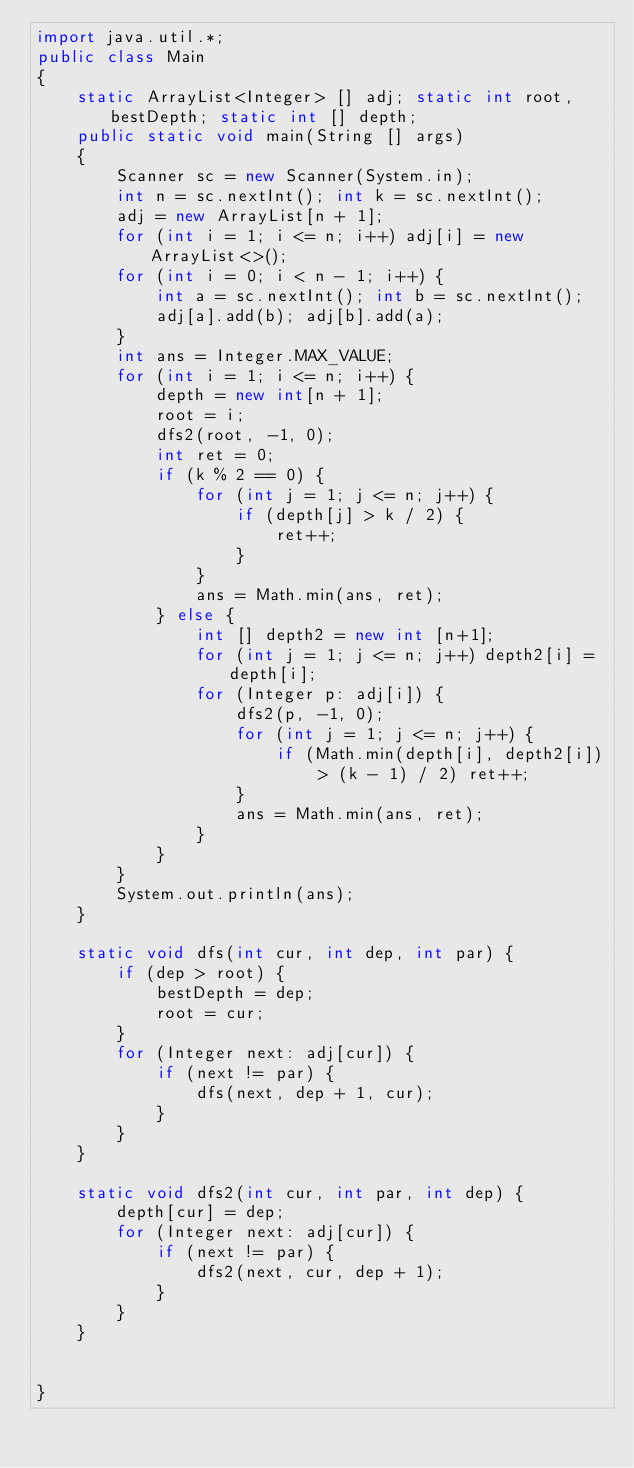Convert code to text. <code><loc_0><loc_0><loc_500><loc_500><_Java_>import java.util.*;
public class Main
{
    static ArrayList<Integer> [] adj; static int root, bestDepth; static int [] depth;
    public static void main(String [] args)
    {
        Scanner sc = new Scanner(System.in);
        int n = sc.nextInt(); int k = sc.nextInt();
        adj = new ArrayList[n + 1];
        for (int i = 1; i <= n; i++) adj[i] = new ArrayList<>();
        for (int i = 0; i < n - 1; i++) {
            int a = sc.nextInt(); int b = sc.nextInt();
            adj[a].add(b); adj[b].add(a);
        }
        int ans = Integer.MAX_VALUE;
        for (int i = 1; i <= n; i++) {
            depth = new int[n + 1];
            root = i;
            dfs2(root, -1, 0);
            int ret = 0;
            if (k % 2 == 0) {
                for (int j = 1; j <= n; j++) {
                    if (depth[j] > k / 2) {
                        ret++;
                    }
                }
                ans = Math.min(ans, ret);
            } else {
                int [] depth2 = new int [n+1];
                for (int j = 1; j <= n; j++) depth2[i] = depth[i];
                for (Integer p: adj[i]) {
                    dfs2(p, -1, 0);
                    for (int j = 1; j <= n; j++) {
                        if (Math.min(depth[i], depth2[i]) > (k - 1) / 2) ret++;
                    }
                    ans = Math.min(ans, ret);
                }
            }
        }
        System.out.println(ans);
    }

    static void dfs(int cur, int dep, int par) {
        if (dep > root) {
            bestDepth = dep;
            root = cur;
        }
        for (Integer next: adj[cur]) {
            if (next != par) {
                dfs(next, dep + 1, cur);
            }
        }
    }

    static void dfs2(int cur, int par, int dep) {
        depth[cur] = dep;
        for (Integer next: adj[cur]) {
            if (next != par) {
                dfs2(next, cur, dep + 1);
            }
        }
    }


}
</code> 